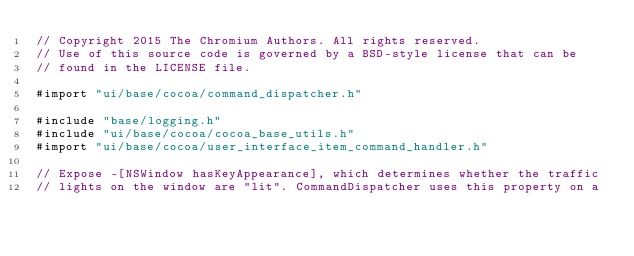Convert code to text. <code><loc_0><loc_0><loc_500><loc_500><_ObjectiveC_>// Copyright 2015 The Chromium Authors. All rights reserved.
// Use of this source code is governed by a BSD-style license that can be
// found in the LICENSE file.

#import "ui/base/cocoa/command_dispatcher.h"

#include "base/logging.h"
#include "ui/base/cocoa/cocoa_base_utils.h"
#import "ui/base/cocoa/user_interface_item_command_handler.h"

// Expose -[NSWindow hasKeyAppearance], which determines whether the traffic
// lights on the window are "lit". CommandDispatcher uses this property on a</code> 